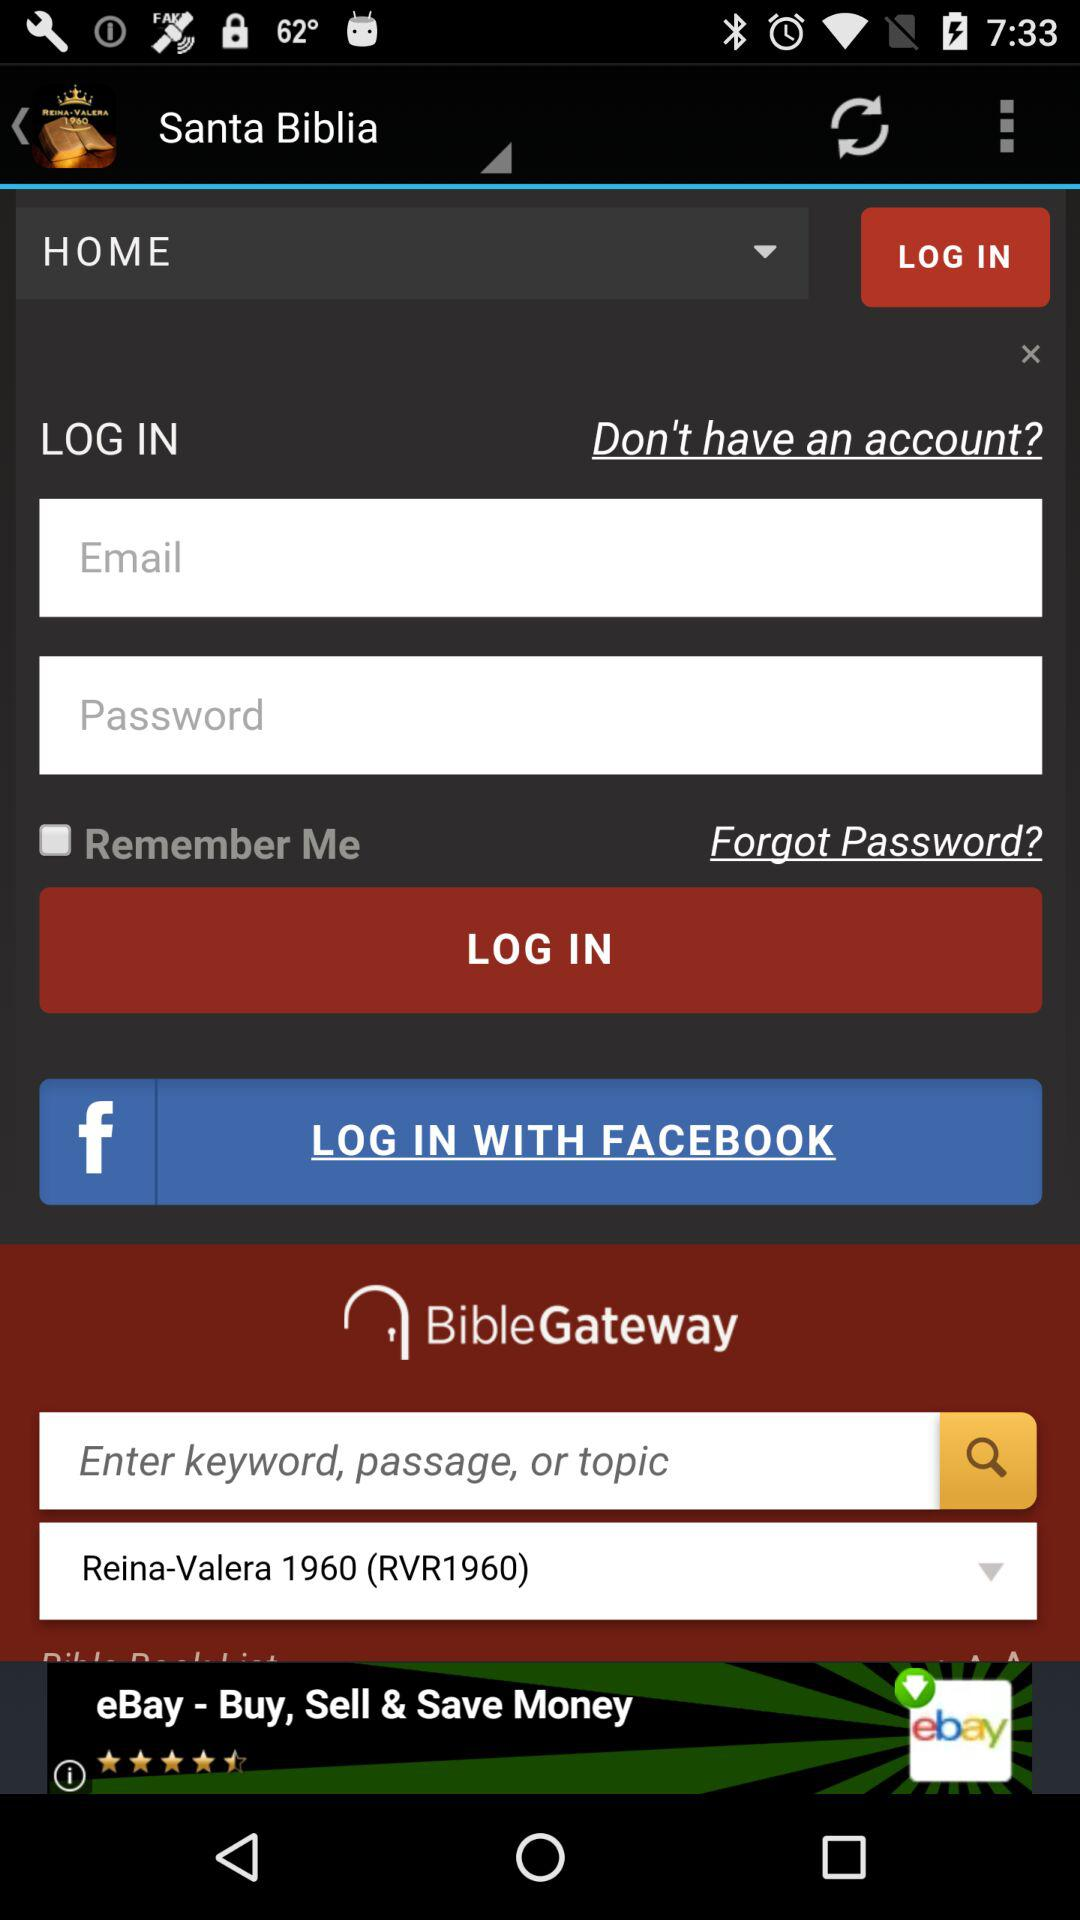What is the name of user?
When the provided information is insufficient, respond with <no answer>. <no answer> 